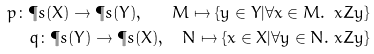<formula> <loc_0><loc_0><loc_500><loc_500>p \colon \P s ( X ) \to \P s ( Y ) , \quad M \mapsto \{ y \in Y | \forall x \in M . \ x Z y \} \\ q \colon \P s ( Y ) \to \P s ( X ) , \quad N \mapsto \{ x \in X | \forall y \in N . \ x Z y \}</formula> 